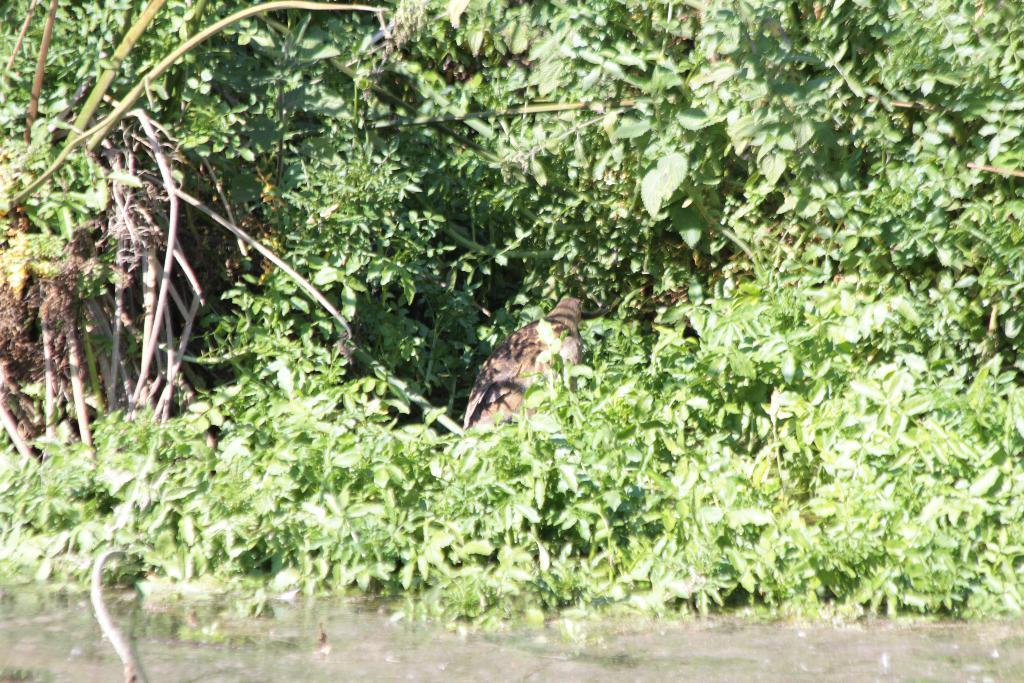What is at the bottom of the image? There is water at the bottom of the image. What can be seen in the foreground of the image? There is a bird in the foreground of the image. What is visible in the background of the image? There are trees in the background of the image. Can you describe the corners of the image? There are trees in both the left and right corners of the image. What type of poison is the bird holding in its beak in the image? There is no poison present in the image; the bird is not holding anything in its beak. 